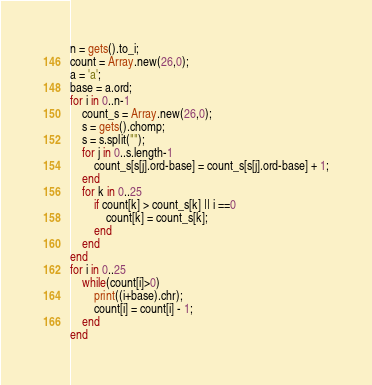<code> <loc_0><loc_0><loc_500><loc_500><_Ruby_>n = gets().to_i;
count = Array.new(26,0);
a = 'a';
base = a.ord; 
for i in 0..n-1
	count_s = Array.new(26,0);
	s = gets().chomp;
	s = s.split("");
	for j in 0..s.length-1
		count_s[s[j].ord-base] = count_s[s[j].ord-base] + 1;
	end
	for k in 0..25
		if count[k] > count_s[k] || i ==0
			count[k] = count_s[k];
		end
	end
end
for i in 0..25
	while(count[i]>0)
		print((i+base).chr);
		count[i] = count[i] - 1;
	end
end</code> 